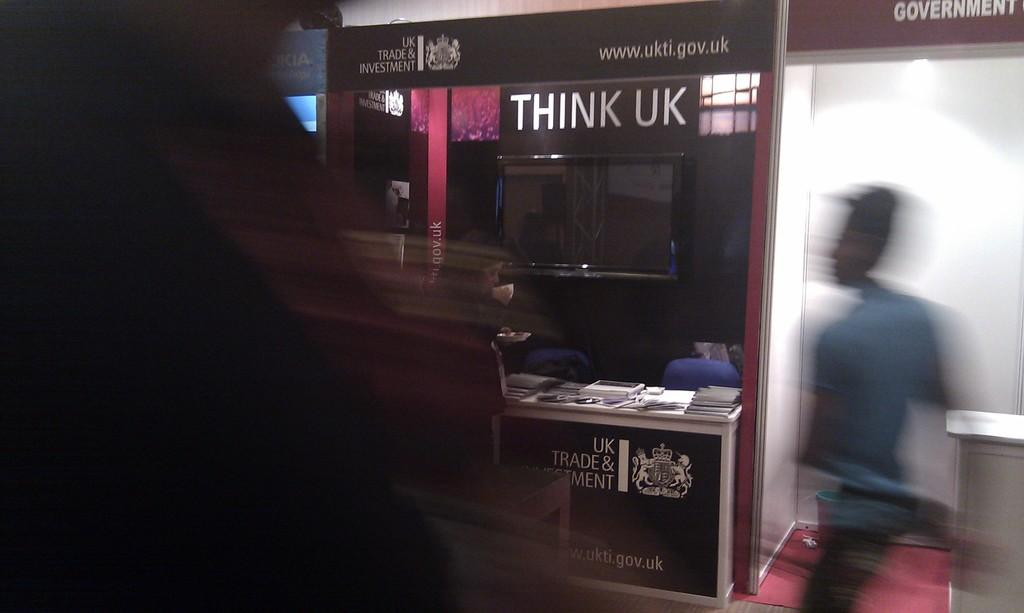Provide a one-sentence caption for the provided image. A man walks past a display for Think UK. 